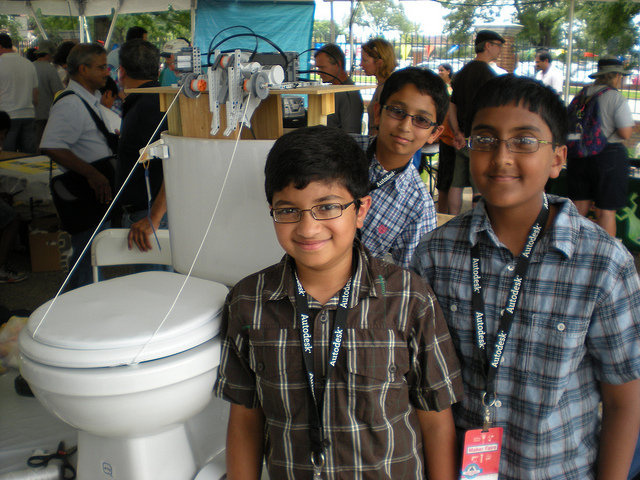Identify the text displayed in this image. Autodesk Autodesk Autodesk Autodesk Autodesk Autodesk Autodesk Autodesk Autodesk Autodesk 